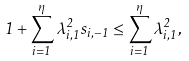<formula> <loc_0><loc_0><loc_500><loc_500>1 + \sum _ { i = 1 } ^ { \eta } \lambda _ { i , 1 } ^ { 2 } s _ { i , - 1 } \leq \sum _ { i = 1 } ^ { \eta } \lambda _ { i , 1 } ^ { 2 } ,</formula> 